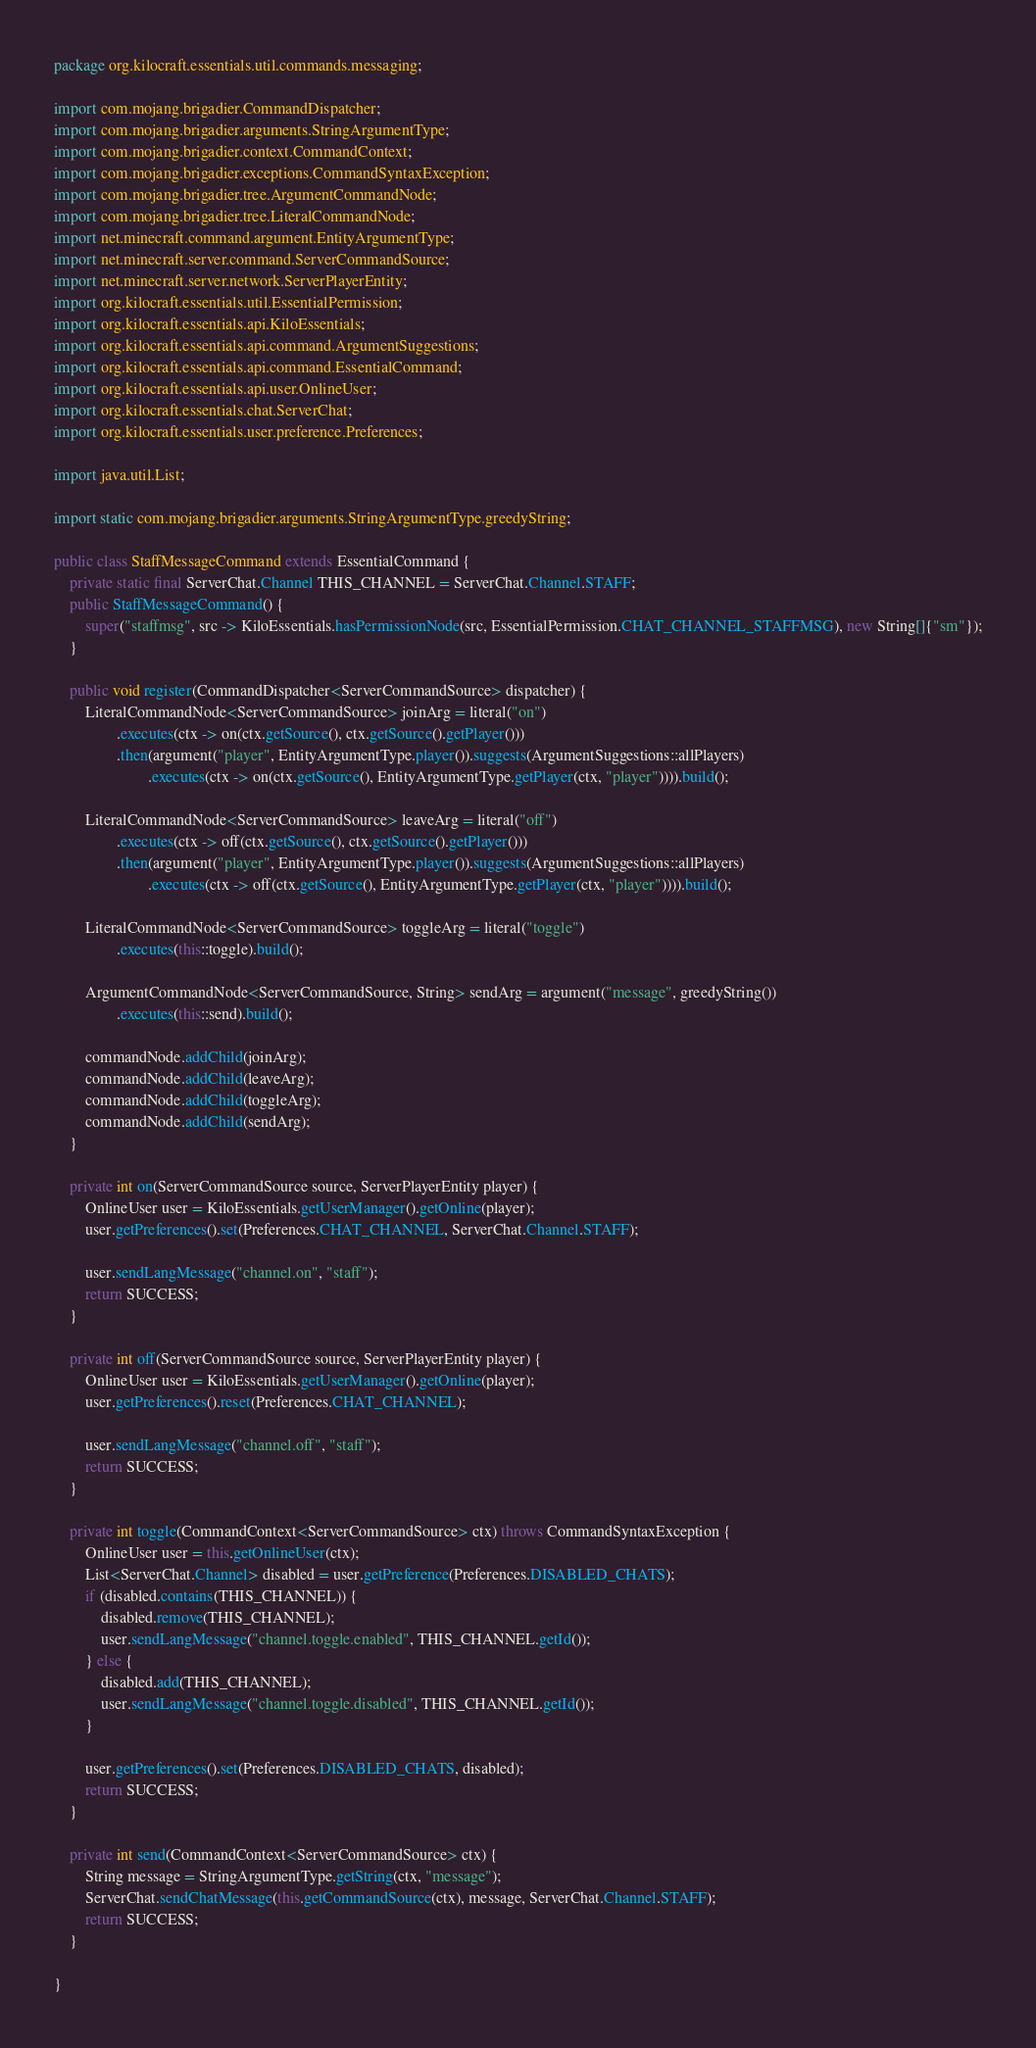Convert code to text. <code><loc_0><loc_0><loc_500><loc_500><_Java_>package org.kilocraft.essentials.util.commands.messaging;

import com.mojang.brigadier.CommandDispatcher;
import com.mojang.brigadier.arguments.StringArgumentType;
import com.mojang.brigadier.context.CommandContext;
import com.mojang.brigadier.exceptions.CommandSyntaxException;
import com.mojang.brigadier.tree.ArgumentCommandNode;
import com.mojang.brigadier.tree.LiteralCommandNode;
import net.minecraft.command.argument.EntityArgumentType;
import net.minecraft.server.command.ServerCommandSource;
import net.minecraft.server.network.ServerPlayerEntity;
import org.kilocraft.essentials.util.EssentialPermission;
import org.kilocraft.essentials.api.KiloEssentials;
import org.kilocraft.essentials.api.command.ArgumentSuggestions;
import org.kilocraft.essentials.api.command.EssentialCommand;
import org.kilocraft.essentials.api.user.OnlineUser;
import org.kilocraft.essentials.chat.ServerChat;
import org.kilocraft.essentials.user.preference.Preferences;

import java.util.List;

import static com.mojang.brigadier.arguments.StringArgumentType.greedyString;

public class StaffMessageCommand extends EssentialCommand {
    private static final ServerChat.Channel THIS_CHANNEL = ServerChat.Channel.STAFF;
    public StaffMessageCommand() {
        super("staffmsg", src -> KiloEssentials.hasPermissionNode(src, EssentialPermission.CHAT_CHANNEL_STAFFMSG), new String[]{"sm"});
    }

    public void register(CommandDispatcher<ServerCommandSource> dispatcher) {
        LiteralCommandNode<ServerCommandSource> joinArg = literal("on")
                .executes(ctx -> on(ctx.getSource(), ctx.getSource().getPlayer()))
                .then(argument("player", EntityArgumentType.player()).suggests(ArgumentSuggestions::allPlayers)
                        .executes(ctx -> on(ctx.getSource(), EntityArgumentType.getPlayer(ctx, "player")))).build();

        LiteralCommandNode<ServerCommandSource> leaveArg = literal("off")
                .executes(ctx -> off(ctx.getSource(), ctx.getSource().getPlayer()))
                .then(argument("player", EntityArgumentType.player()).suggests(ArgumentSuggestions::allPlayers)
                        .executes(ctx -> off(ctx.getSource(), EntityArgumentType.getPlayer(ctx, "player")))).build();

        LiteralCommandNode<ServerCommandSource> toggleArg = literal("toggle")
                .executes(this::toggle).build();

        ArgumentCommandNode<ServerCommandSource, String> sendArg = argument("message", greedyString())
                .executes(this::send).build();

        commandNode.addChild(joinArg);
        commandNode.addChild(leaveArg);
        commandNode.addChild(toggleArg);
        commandNode.addChild(sendArg);
    }

    private int on(ServerCommandSource source, ServerPlayerEntity player) {
        OnlineUser user = KiloEssentials.getUserManager().getOnline(player);
        user.getPreferences().set(Preferences.CHAT_CHANNEL, ServerChat.Channel.STAFF);

        user.sendLangMessage("channel.on", "staff");
        return SUCCESS;
    }

    private int off(ServerCommandSource source, ServerPlayerEntity player) {
        OnlineUser user = KiloEssentials.getUserManager().getOnline(player);
        user.getPreferences().reset(Preferences.CHAT_CHANNEL);

        user.sendLangMessage("channel.off", "staff");
        return SUCCESS;
    }

    private int toggle(CommandContext<ServerCommandSource> ctx) throws CommandSyntaxException {
        OnlineUser user = this.getOnlineUser(ctx);
        List<ServerChat.Channel> disabled = user.getPreference(Preferences.DISABLED_CHATS);
        if (disabled.contains(THIS_CHANNEL)) {
            disabled.remove(THIS_CHANNEL);
            user.sendLangMessage("channel.toggle.enabled", THIS_CHANNEL.getId());
        } else {
            disabled.add(THIS_CHANNEL);
            user.sendLangMessage("channel.toggle.disabled", THIS_CHANNEL.getId());
        }

        user.getPreferences().set(Preferences.DISABLED_CHATS, disabled);
        return SUCCESS;
    }

    private int send(CommandContext<ServerCommandSource> ctx) {
        String message = StringArgumentType.getString(ctx, "message");
        ServerChat.sendChatMessage(this.getCommandSource(ctx), message, ServerChat.Channel.STAFF);
        return SUCCESS;
    }

}
</code> 